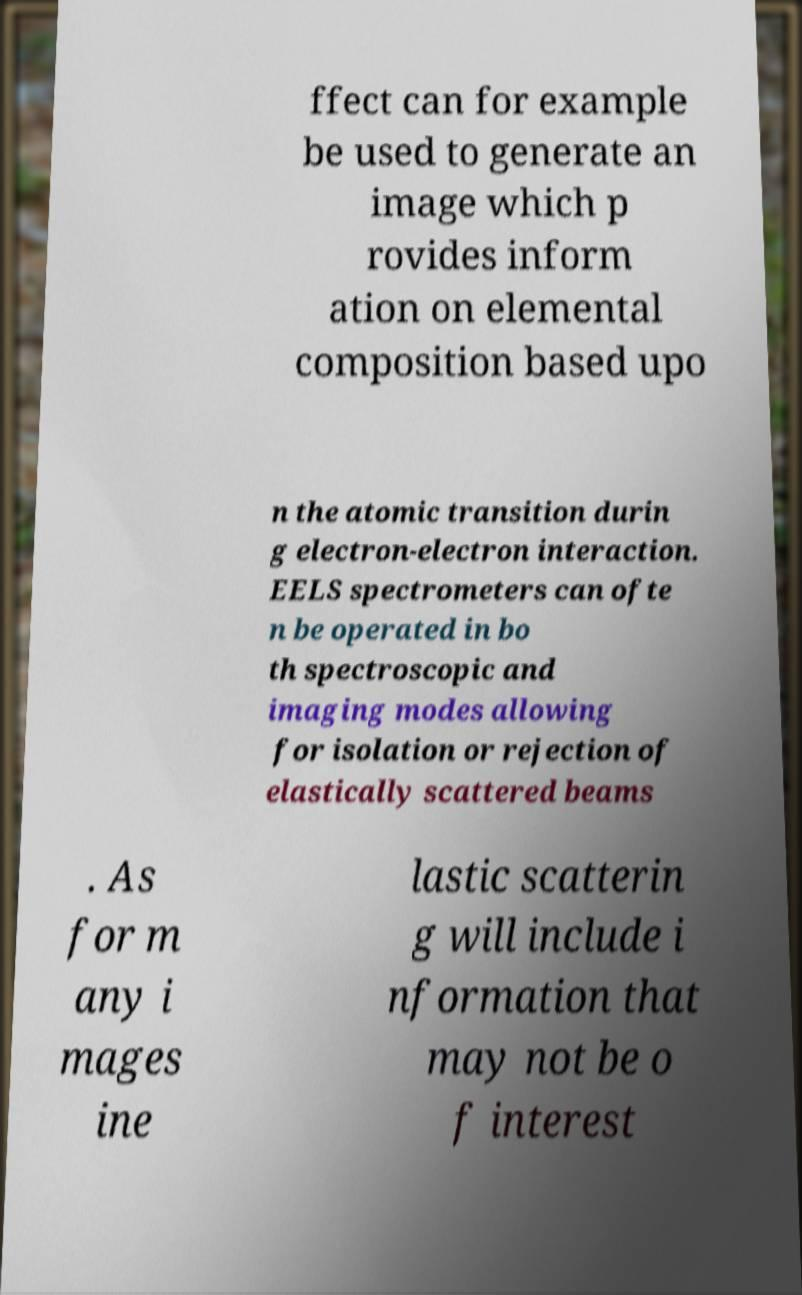What messages or text are displayed in this image? I need them in a readable, typed format. ffect can for example be used to generate an image which p rovides inform ation on elemental composition based upo n the atomic transition durin g electron-electron interaction. EELS spectrometers can ofte n be operated in bo th spectroscopic and imaging modes allowing for isolation or rejection of elastically scattered beams . As for m any i mages ine lastic scatterin g will include i nformation that may not be o f interest 